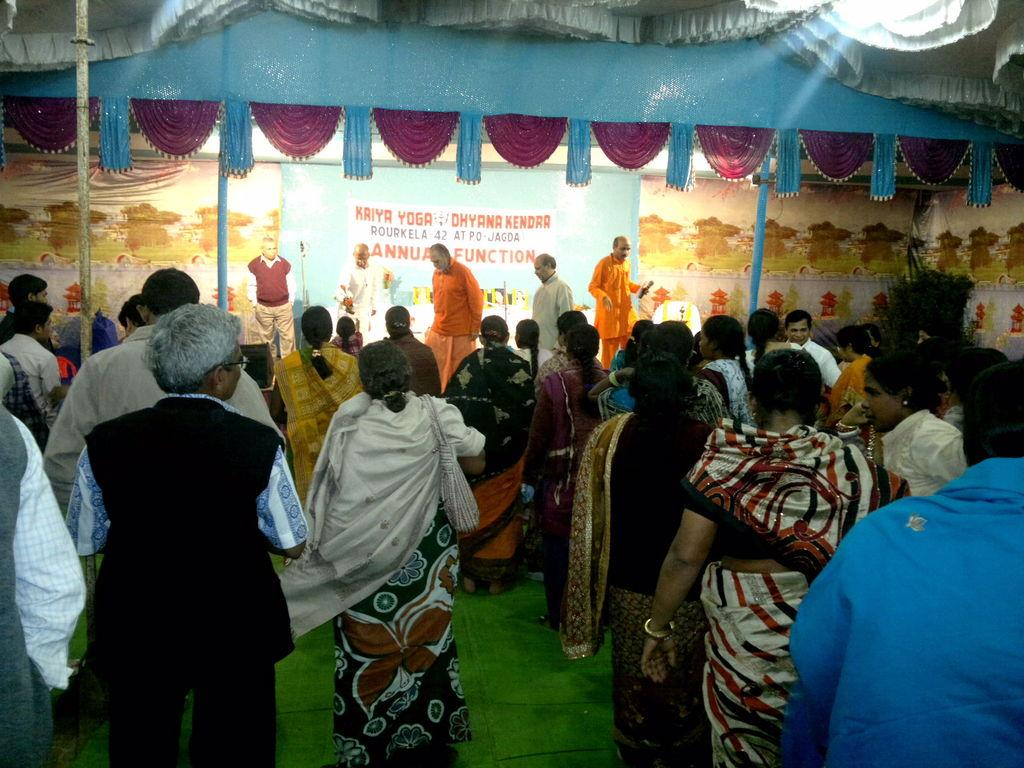Who or what can be seen in the image? There are people in the image. What is on the ground in the image? There is a mat in the image. What is hanging or attached to something in the image? There is a banner in the image. What is a large, flat, and stationary surface in the image? There is a wall in the image. What type of knife is being used by the people in the image? There is no knife present in the image. How many shoes can be seen on the people in the image? The image does not show any shoes on the people. 